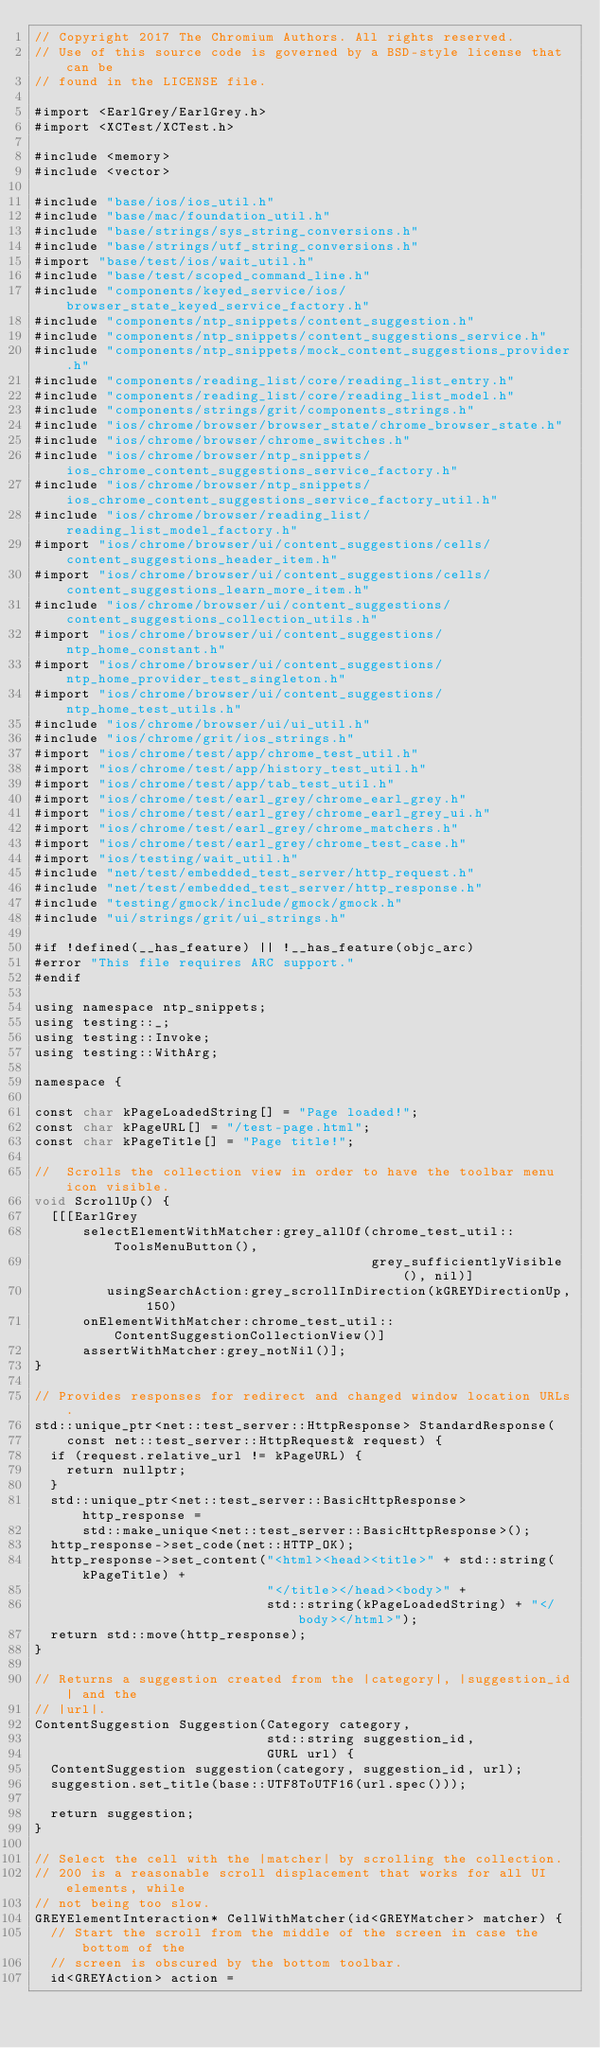Convert code to text. <code><loc_0><loc_0><loc_500><loc_500><_ObjectiveC_>// Copyright 2017 The Chromium Authors. All rights reserved.
// Use of this source code is governed by a BSD-style license that can be
// found in the LICENSE file.

#import <EarlGrey/EarlGrey.h>
#import <XCTest/XCTest.h>

#include <memory>
#include <vector>

#include "base/ios/ios_util.h"
#include "base/mac/foundation_util.h"
#include "base/strings/sys_string_conversions.h"
#include "base/strings/utf_string_conversions.h"
#import "base/test/ios/wait_util.h"
#include "base/test/scoped_command_line.h"
#include "components/keyed_service/ios/browser_state_keyed_service_factory.h"
#include "components/ntp_snippets/content_suggestion.h"
#include "components/ntp_snippets/content_suggestions_service.h"
#include "components/ntp_snippets/mock_content_suggestions_provider.h"
#include "components/reading_list/core/reading_list_entry.h"
#include "components/reading_list/core/reading_list_model.h"
#include "components/strings/grit/components_strings.h"
#include "ios/chrome/browser/browser_state/chrome_browser_state.h"
#include "ios/chrome/browser/chrome_switches.h"
#include "ios/chrome/browser/ntp_snippets/ios_chrome_content_suggestions_service_factory.h"
#include "ios/chrome/browser/ntp_snippets/ios_chrome_content_suggestions_service_factory_util.h"
#include "ios/chrome/browser/reading_list/reading_list_model_factory.h"
#import "ios/chrome/browser/ui/content_suggestions/cells/content_suggestions_header_item.h"
#import "ios/chrome/browser/ui/content_suggestions/cells/content_suggestions_learn_more_item.h"
#include "ios/chrome/browser/ui/content_suggestions/content_suggestions_collection_utils.h"
#import "ios/chrome/browser/ui/content_suggestions/ntp_home_constant.h"
#import "ios/chrome/browser/ui/content_suggestions/ntp_home_provider_test_singleton.h"
#import "ios/chrome/browser/ui/content_suggestions/ntp_home_test_utils.h"
#include "ios/chrome/browser/ui/ui_util.h"
#include "ios/chrome/grit/ios_strings.h"
#import "ios/chrome/test/app/chrome_test_util.h"
#import "ios/chrome/test/app/history_test_util.h"
#import "ios/chrome/test/app/tab_test_util.h"
#import "ios/chrome/test/earl_grey/chrome_earl_grey.h"
#import "ios/chrome/test/earl_grey/chrome_earl_grey_ui.h"
#import "ios/chrome/test/earl_grey/chrome_matchers.h"
#import "ios/chrome/test/earl_grey/chrome_test_case.h"
#import "ios/testing/wait_util.h"
#include "net/test/embedded_test_server/http_request.h"
#include "net/test/embedded_test_server/http_response.h"
#include "testing/gmock/include/gmock/gmock.h"
#include "ui/strings/grit/ui_strings.h"

#if !defined(__has_feature) || !__has_feature(objc_arc)
#error "This file requires ARC support."
#endif

using namespace ntp_snippets;
using testing::_;
using testing::Invoke;
using testing::WithArg;

namespace {

const char kPageLoadedString[] = "Page loaded!";
const char kPageURL[] = "/test-page.html";
const char kPageTitle[] = "Page title!";

//  Scrolls the collection view in order to have the toolbar menu icon visible.
void ScrollUp() {
  [[[EarlGrey
      selectElementWithMatcher:grey_allOf(chrome_test_util::ToolsMenuButton(),
                                          grey_sufficientlyVisible(), nil)]
         usingSearchAction:grey_scrollInDirection(kGREYDirectionUp, 150)
      onElementWithMatcher:chrome_test_util::ContentSuggestionCollectionView()]
      assertWithMatcher:grey_notNil()];
}

// Provides responses for redirect and changed window location URLs.
std::unique_ptr<net::test_server::HttpResponse> StandardResponse(
    const net::test_server::HttpRequest& request) {
  if (request.relative_url != kPageURL) {
    return nullptr;
  }
  std::unique_ptr<net::test_server::BasicHttpResponse> http_response =
      std::make_unique<net::test_server::BasicHttpResponse>();
  http_response->set_code(net::HTTP_OK);
  http_response->set_content("<html><head><title>" + std::string(kPageTitle) +
                             "</title></head><body>" +
                             std::string(kPageLoadedString) + "</body></html>");
  return std::move(http_response);
}

// Returns a suggestion created from the |category|, |suggestion_id| and the
// |url|.
ContentSuggestion Suggestion(Category category,
                             std::string suggestion_id,
                             GURL url) {
  ContentSuggestion suggestion(category, suggestion_id, url);
  suggestion.set_title(base::UTF8ToUTF16(url.spec()));

  return suggestion;
}

// Select the cell with the |matcher| by scrolling the collection.
// 200 is a reasonable scroll displacement that works for all UI elements, while
// not being too slow.
GREYElementInteraction* CellWithMatcher(id<GREYMatcher> matcher) {
  // Start the scroll from the middle of the screen in case the bottom of the
  // screen is obscured by the bottom toolbar.
  id<GREYAction> action =</code> 